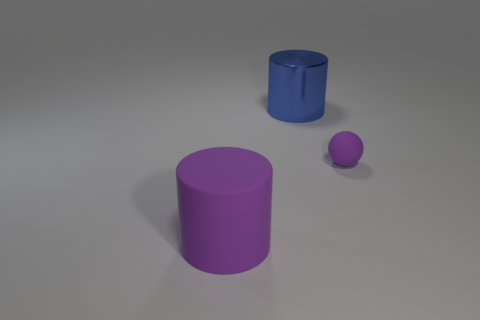How many cylinders are large purple objects or big shiny things?
Your response must be concise. 2. Does the blue metal object have the same shape as the purple matte thing left of the tiny sphere?
Your answer should be very brief. Yes. There is a thing that is both in front of the blue metal cylinder and on the left side of the small purple rubber thing; what size is it?
Offer a very short reply. Large. The big blue object has what shape?
Your answer should be very brief. Cylinder. Are there any large objects that are behind the purple object that is in front of the tiny ball?
Offer a very short reply. Yes. There is a big cylinder that is behind the purple rubber cylinder; what number of large purple rubber things are to the left of it?
Provide a succinct answer. 1. There is a blue cylinder that is the same size as the purple rubber cylinder; what is its material?
Offer a terse response. Metal. There is a blue object behind the tiny purple thing; is its shape the same as the small purple thing?
Provide a short and direct response. No. Are there more large purple objects behind the blue thing than big rubber objects in front of the big matte object?
Your answer should be very brief. No. How many other spheres have the same material as the purple ball?
Provide a succinct answer. 0. 